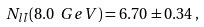<formula> <loc_0><loc_0><loc_500><loc_500>N _ { l \bar { l } } ( 8 . 0 \ G e V ) = 6 . 7 0 \pm 0 . 3 4 \, ,</formula> 